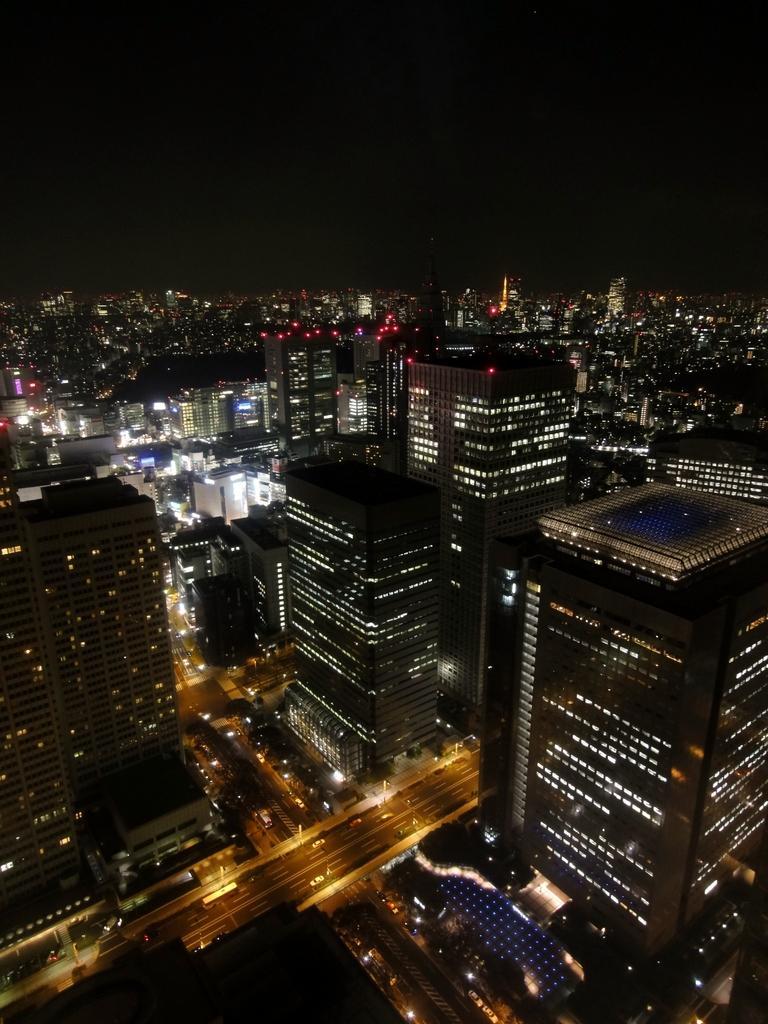Describe this image in one or two sentences. In this image I can see number of buildings, number of lights, the road and few vehicles on the road. In the background I can see the sky. 